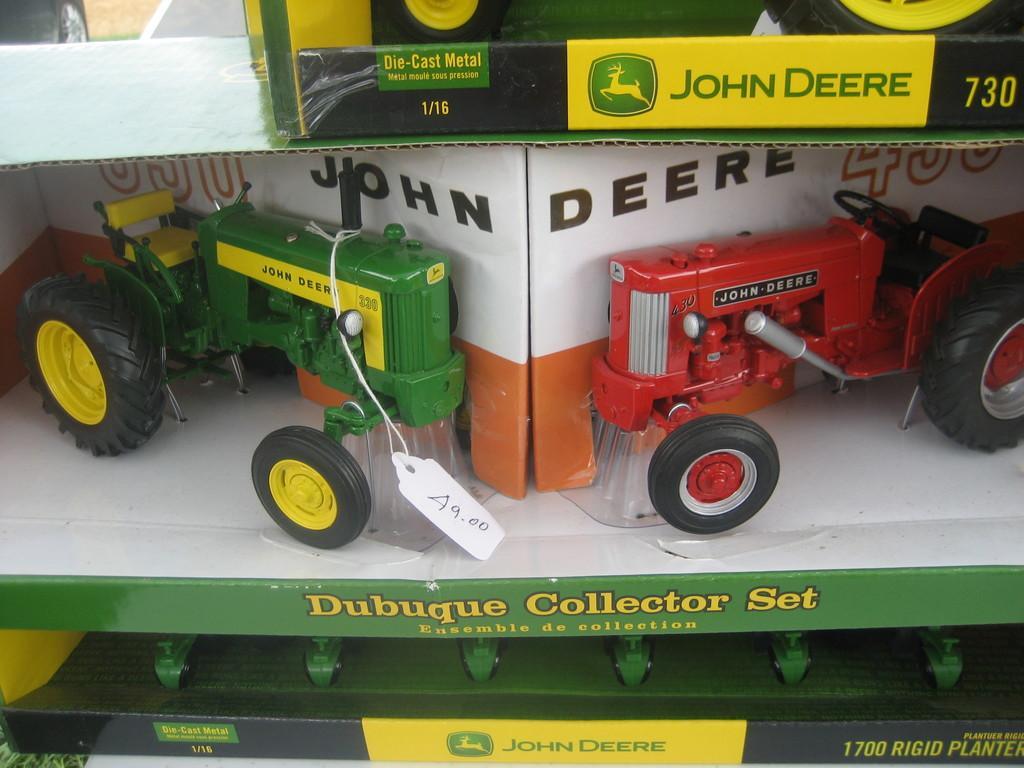How would you summarize this image in a sentence or two? In this image, we can see toy tractors and few toys with the boxes. Here we can see a price tag with thread. 